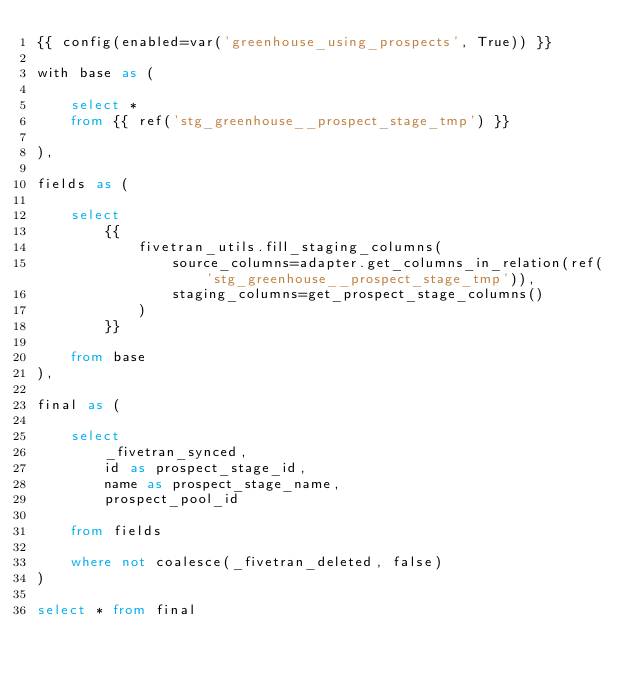<code> <loc_0><loc_0><loc_500><loc_500><_SQL_>{{ config(enabled=var('greenhouse_using_prospects', True)) }}

with base as (

    select * 
    from {{ ref('stg_greenhouse__prospect_stage_tmp') }}

),

fields as (

    select
        {{
            fivetran_utils.fill_staging_columns(
                source_columns=adapter.get_columns_in_relation(ref('stg_greenhouse__prospect_stage_tmp')),
                staging_columns=get_prospect_stage_columns()
            )
        }}
        
    from base
),

final as (
    
    select 
        _fivetran_synced,
        id as prospect_stage_id,
        name as prospect_stage_name,
        prospect_pool_id
        
    from fields

    where not coalesce(_fivetran_deleted, false)
)

select * from final
</code> 